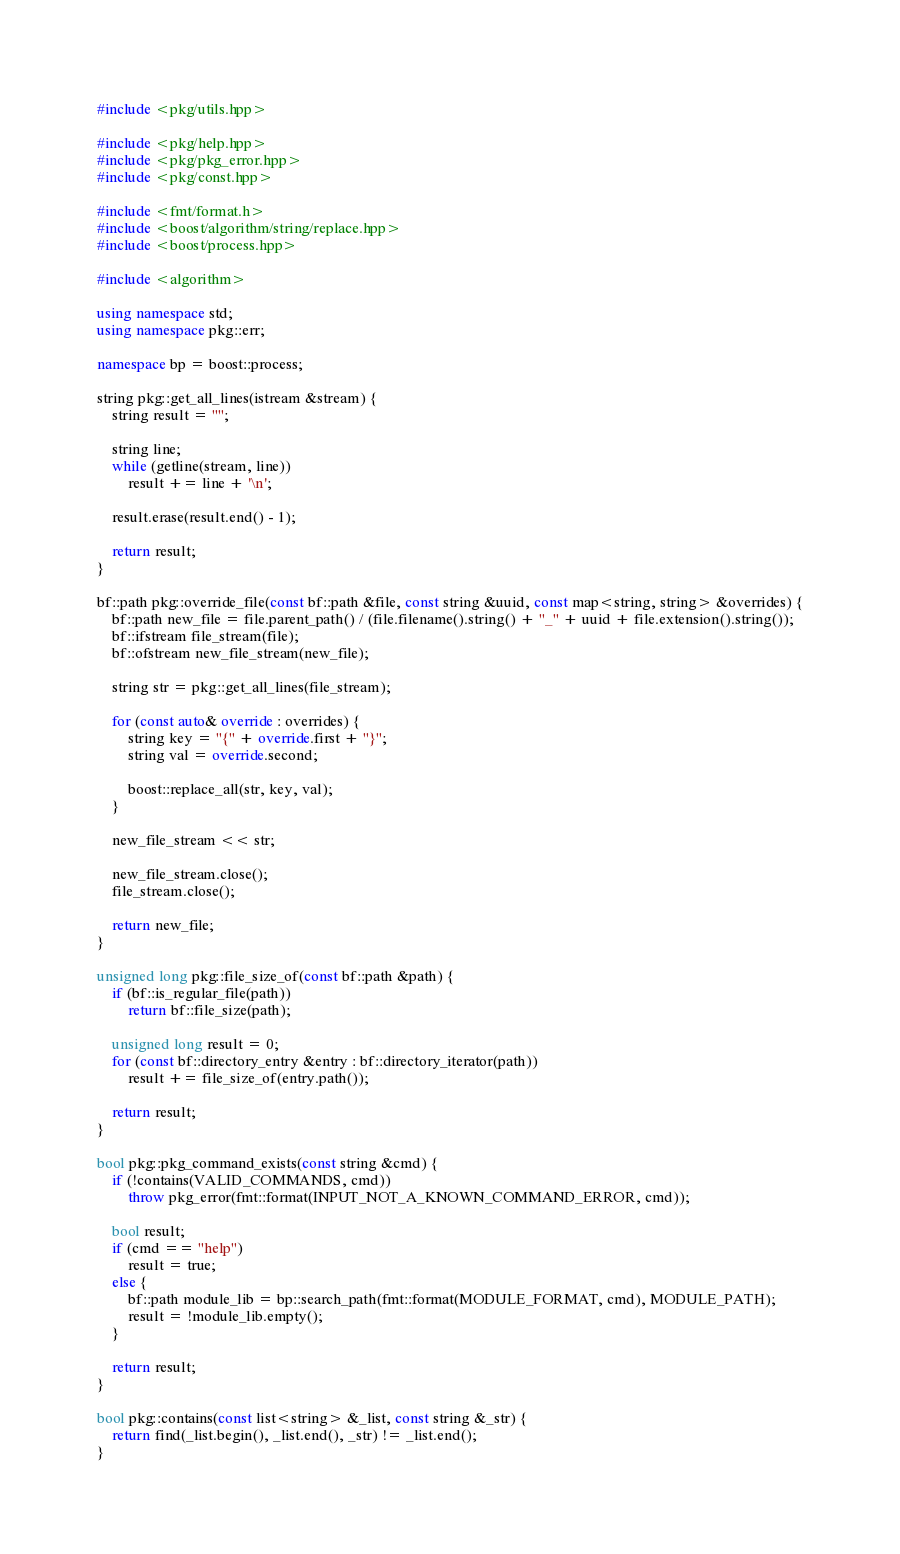Convert code to text. <code><loc_0><loc_0><loc_500><loc_500><_C++_>#include <pkg/utils.hpp>

#include <pkg/help.hpp>
#include <pkg/pkg_error.hpp>
#include <pkg/const.hpp>

#include <fmt/format.h>
#include <boost/algorithm/string/replace.hpp>
#include <boost/process.hpp>

#include <algorithm>

using namespace std;
using namespace pkg::err;

namespace bp = boost::process;

string pkg::get_all_lines(istream &stream) {
    string result = "";

    string line;
    while (getline(stream, line))
        result += line + '\n';

    result.erase(result.end() - 1);

    return result;
}

bf::path pkg::override_file(const bf::path &file, const string &uuid, const map<string, string> &overrides) {
    bf::path new_file = file.parent_path() / (file.filename().string() + "_" + uuid + file.extension().string());
    bf::ifstream file_stream(file);
    bf::ofstream new_file_stream(new_file);

    string str = pkg::get_all_lines(file_stream);

    for (const auto& override : overrides) {
        string key = "{" + override.first + "}";
        string val = override.second;

        boost::replace_all(str, key, val);
    }

    new_file_stream << str;

    new_file_stream.close();
    file_stream.close();

    return new_file;
}

unsigned long pkg::file_size_of(const bf::path &path) {
    if (bf::is_regular_file(path))
        return bf::file_size(path);
    
    unsigned long result = 0;
    for (const bf::directory_entry &entry : bf::directory_iterator(path))
        result += file_size_of(entry.path());

    return result;
}

bool pkg::pkg_command_exists(const string &cmd) {
    if (!contains(VALID_COMMANDS, cmd))
        throw pkg_error(fmt::format(INPUT_NOT_A_KNOWN_COMMAND_ERROR, cmd));

    bool result;
    if (cmd == "help")
        result = true;
    else {
        bf::path module_lib = bp::search_path(fmt::format(MODULE_FORMAT, cmd), MODULE_PATH);
        result = !module_lib.empty();
    }

    return result;
}

bool pkg::contains(const list<string> &_list, const string &_str) {
    return find(_list.begin(), _list.end(), _str) != _list.end();
}</code> 